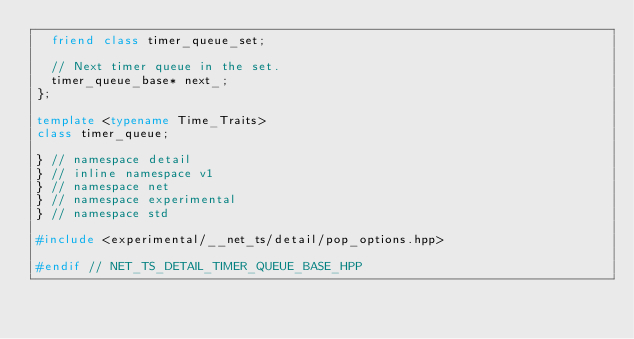<code> <loc_0><loc_0><loc_500><loc_500><_C++_>  friend class timer_queue_set;

  // Next timer queue in the set.
  timer_queue_base* next_;
};

template <typename Time_Traits>
class timer_queue;

} // namespace detail
} // inline namespace v1
} // namespace net
} // namespace experimental
} // namespace std

#include <experimental/__net_ts/detail/pop_options.hpp>

#endif // NET_TS_DETAIL_TIMER_QUEUE_BASE_HPP
</code> 